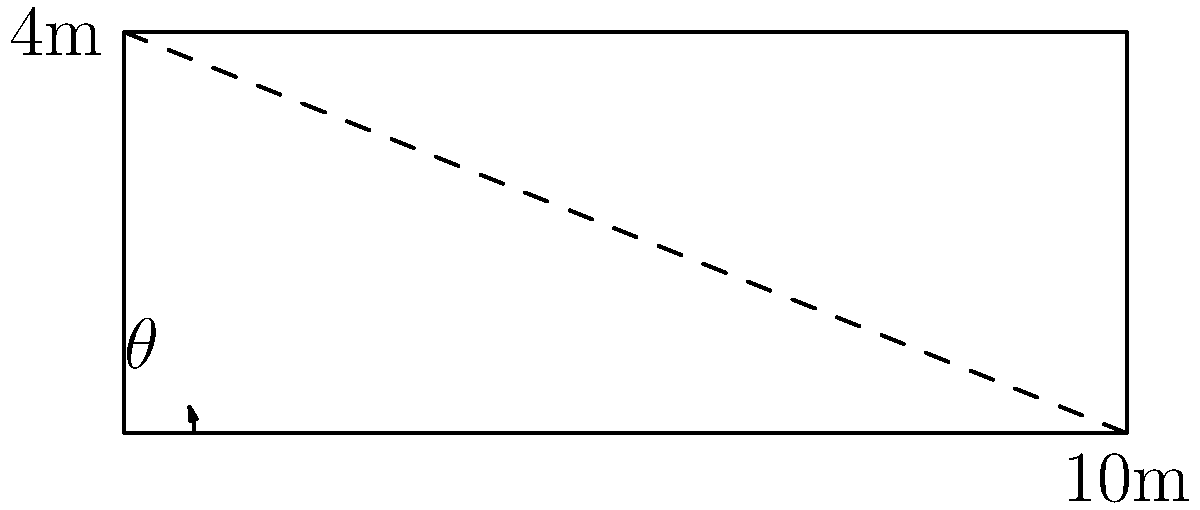On a speedway track, you're designing a banked turn. The turn has a width of 10 meters and a height difference of 4 meters from the inside to the outside edge. What is the angle of the banking in degrees? To solve this problem, we'll use the tangent function from trigonometry. Here's the step-by-step solution:

1) In a right triangle, the tangent of an angle is the ratio of the opposite side to the adjacent side.

2) In our case:
   - The opposite side is the height difference: 4 meters
   - The adjacent side is the width of the turn: 10 meters

3) We can express this as:

   $\tan(\theta) = \frac{\text{opposite}}{\text{adjacent}} = \frac{4}{10} = 0.4$

4) To find the angle $\theta$, we need to use the inverse tangent (arctan or $\tan^{-1}$) function:

   $\theta = \tan^{-1}(0.4)$

5) Using a calculator or trigonometric tables:

   $\theta \approx 21.80^\circ$

6) Rounding to two decimal places:

   $\theta \approx 21.80^\circ$

Thus, the angle of the banking is approximately 21.80 degrees.
Answer: $21.80^\circ$ 